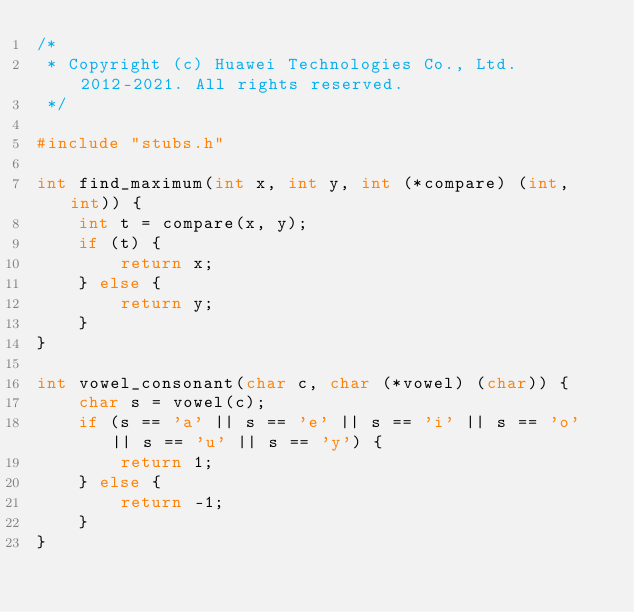<code> <loc_0><loc_0><loc_500><loc_500><_C_>/*
 * Copyright (c) Huawei Technologies Co., Ltd. 2012-2021. All rights reserved.
 */

#include "stubs.h"

int find_maximum(int x, int y, int (*compare) (int, int)) {
    int t = compare(x, y);
    if (t) {
        return x;
    } else {
        return y;
    }
}

int vowel_consonant(char c, char (*vowel) (char)) {
    char s = vowel(c);
    if (s == 'a' || s == 'e' || s == 'i' || s == 'o' || s == 'u' || s == 'y') {
        return 1;
    } else {
        return -1;
    }
}
</code> 